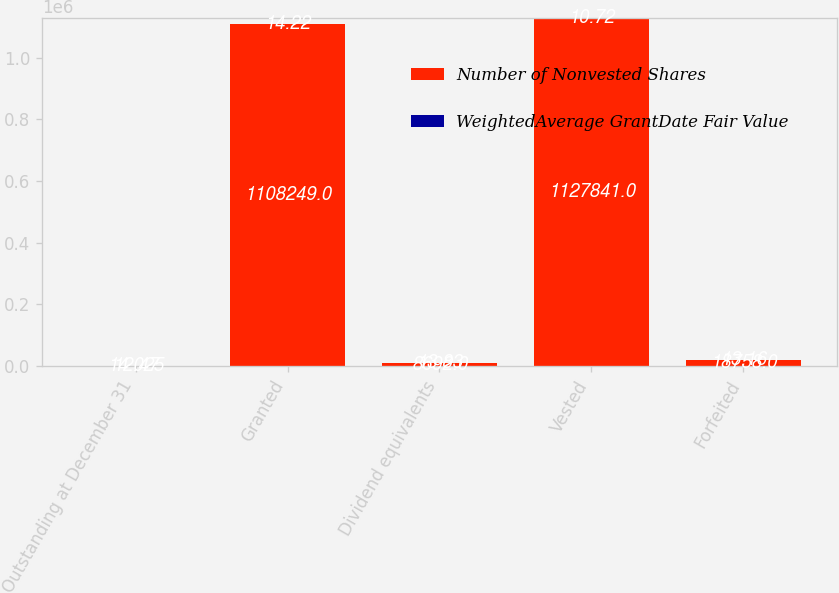Convert chart. <chart><loc_0><loc_0><loc_500><loc_500><stacked_bar_chart><ecel><fcel>Outstanding at December 31<fcel>Granted<fcel>Dividend equivalents<fcel>Vested<fcel>Forfeited<nl><fcel>Number of Nonvested Shares<fcel>14.025<fcel>1.10825e+06<fcel>8692<fcel>1.12784e+06<fcel>18758<nl><fcel>WeightedAverage GrantDate Fair Value<fcel>12.47<fcel>14.22<fcel>13.83<fcel>10.72<fcel>13.16<nl></chart> 